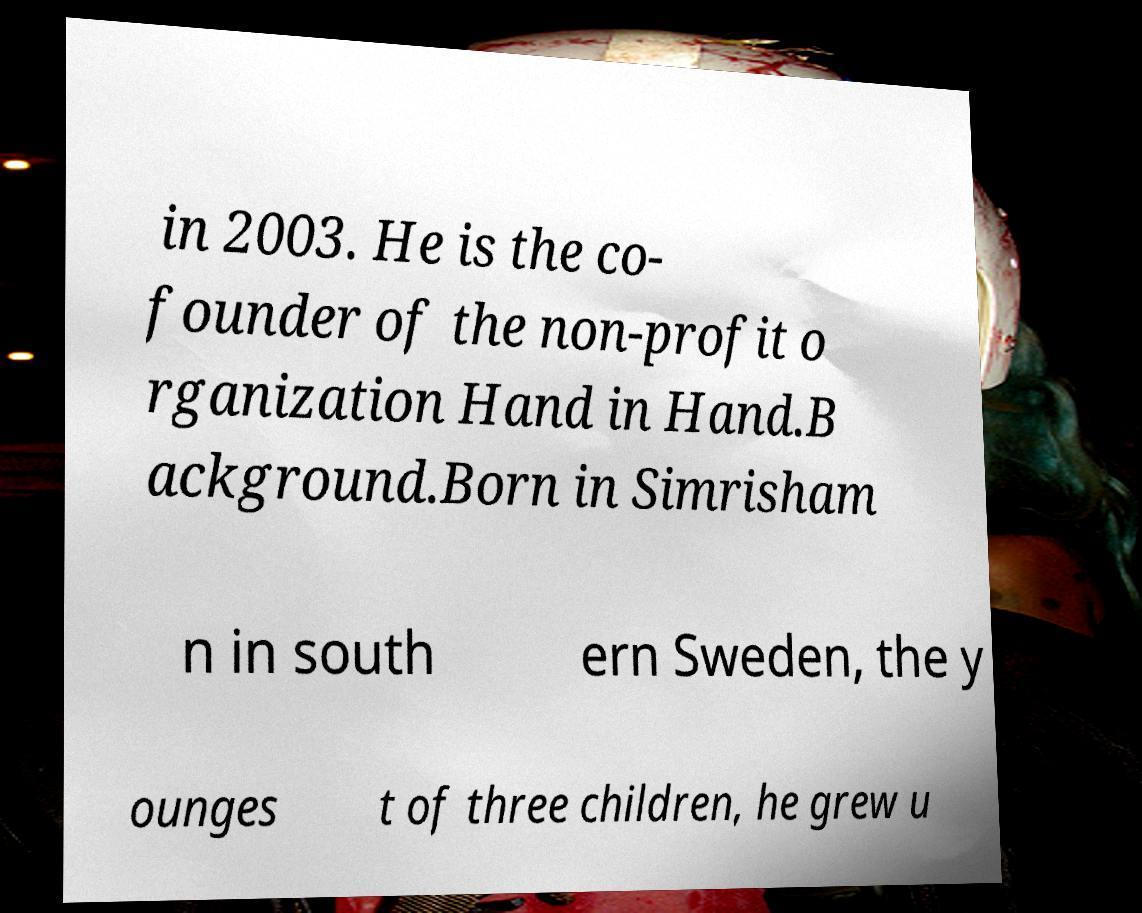For documentation purposes, I need the text within this image transcribed. Could you provide that? in 2003. He is the co- founder of the non-profit o rganization Hand in Hand.B ackground.Born in Simrisham n in south ern Sweden, the y ounges t of three children, he grew u 